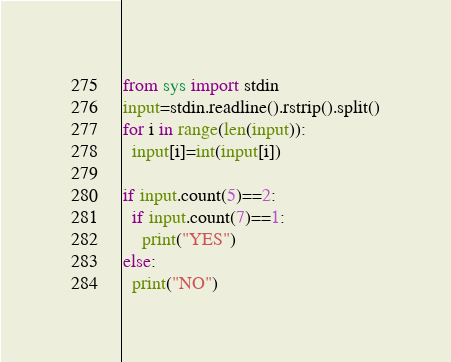<code> <loc_0><loc_0><loc_500><loc_500><_Python_>from sys import stdin
input=stdin.readline().rstrip().split()
for i in range(len(input)):
  input[i]=int(input[i])

if input.count(5)==2:
  if input.count(7)==1:
    print("YES")
else:
  print("NO")</code> 